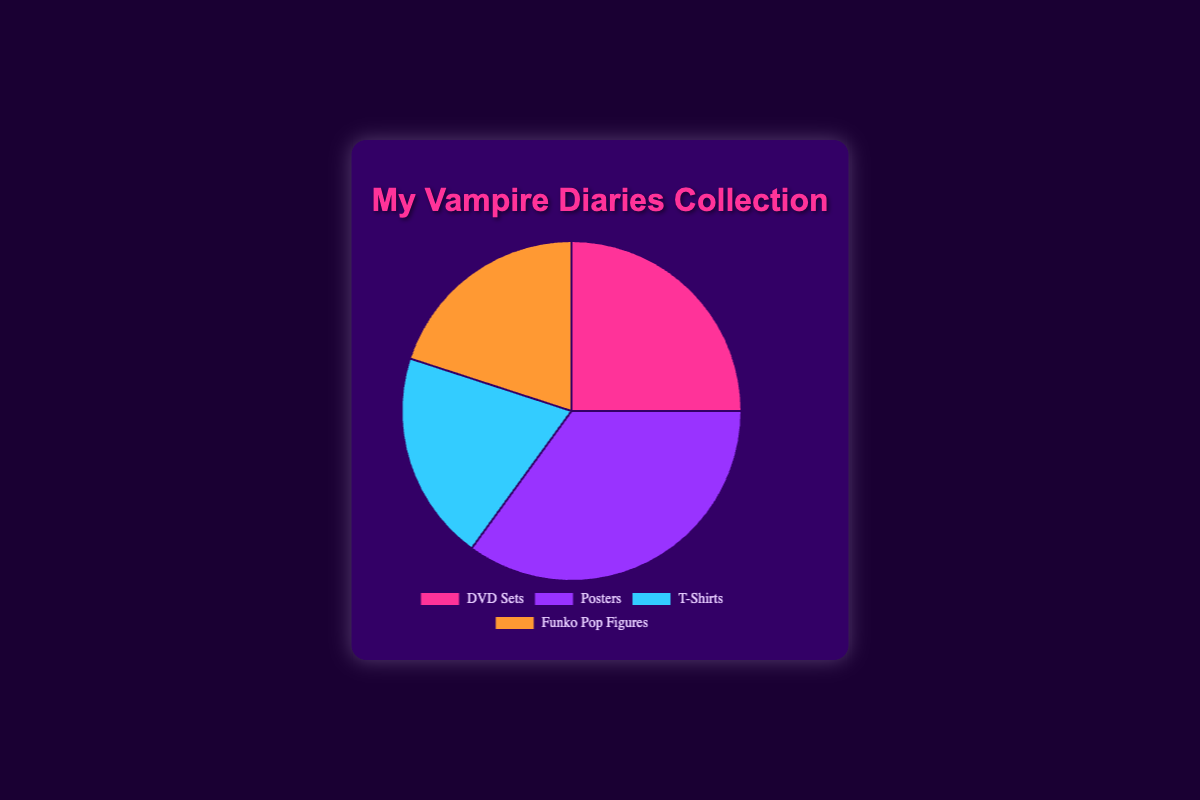Which type of Vampire Diaries merchandise has the highest percentage? The chart indicates four types of merchandise with their respective percentages. By comparing the values, "Posters" has the highest percentage of 35%.
Answer: Posters What is the total percentage of T-Shirts and Funko Pop Figures combined? Adding the percentages of T-Shirts (20%) and Funko Pop Figures (20%), the total is 20 + 20 = 40%.
Answer: 40% How much more popular are Posters compared to DVD Sets? Posters have a percentage of 35%, while DVD Sets have 25%. The difference is 35 - 25 = 10%.
Answer: 10% Which two types of merchandise are equally popular? The pie chart shows that T-Shirts and Funko Pop Figures each have a percentage of 20%. Therefore, they are equally popular.
Answer: T-Shirts and Funko Pop Figures What is the average percentage of DVD Sets, T-Shirts, and Funko Pop Figures? Summing the percentages of DVD Sets (25%), T-Shirts (20%), and Funko Pop Figures (20%) equals 65%. The average of these three types is 65 / 3 ≈ 21.67%.
Answer: 21.67% Which segment is represented by the color orange in the pie chart? Observing the visual attributes, Funko Pop Figures are colored orange in the pie chart.
Answer: Funko Pop Figures If Posters were reduced by 10%, which type of merchandise would have the highest percentage? Reducing Posters by 10% makes it 25%. Thus, the new comparison is DVD Sets (25%), Posters (25%), T-Shirts (20%), and Funko Pop Figures (20%). Both DVD Sets and Posters now share the highest percentage of 25%.
Answer: DVD Sets and Posters What fraction of the total merchandise does DVD Sets represent? DVD Sets account for 25% of the total merchandise. As a fraction, 25% is equal to 25/100 which simplifies to 1/4.
Answer: 1/4 By how much do Posters exceed the average percentage of all merchandise types? The average percentage for the four types of merchandise is the total of 100% divided by 4, which is 25%. Posters have 35%, which is 35 - 25 = 10% above the average.
Answer: 10% If T-Shirts were doubled in percentage, what fraction of the total would they represent? Doubling the percentage of T-Shirts makes it 20% * 2 = 40%. The total would then be 120%, and T-Shirts' fraction would be 40 / 120 = 1/3.
Answer: 1/3 